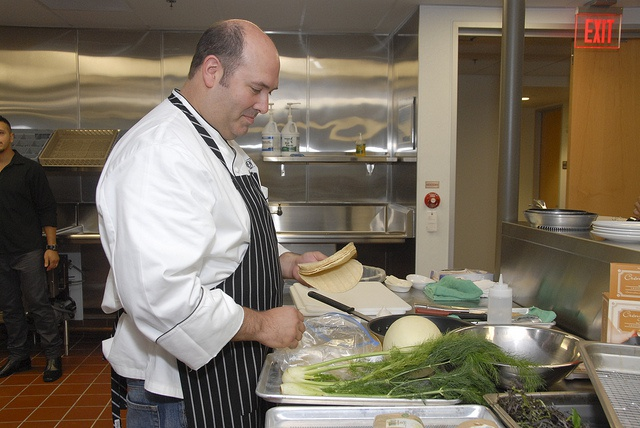Describe the objects in this image and their specific colors. I can see people in black, lightgray, darkgray, and gray tones, people in black, maroon, and brown tones, bowl in black, gray, darkgreen, and white tones, sink in black, gray, and darkgray tones, and bottle in black, darkgray, gray, and white tones in this image. 